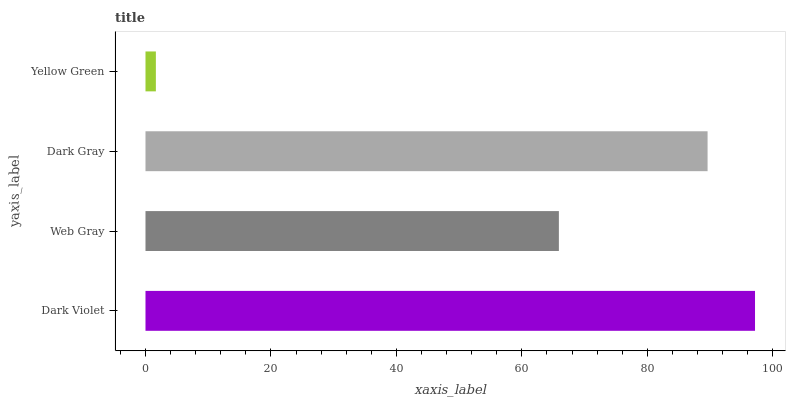Is Yellow Green the minimum?
Answer yes or no. Yes. Is Dark Violet the maximum?
Answer yes or no. Yes. Is Web Gray the minimum?
Answer yes or no. No. Is Web Gray the maximum?
Answer yes or no. No. Is Dark Violet greater than Web Gray?
Answer yes or no. Yes. Is Web Gray less than Dark Violet?
Answer yes or no. Yes. Is Web Gray greater than Dark Violet?
Answer yes or no. No. Is Dark Violet less than Web Gray?
Answer yes or no. No. Is Dark Gray the high median?
Answer yes or no. Yes. Is Web Gray the low median?
Answer yes or no. Yes. Is Yellow Green the high median?
Answer yes or no. No. Is Dark Violet the low median?
Answer yes or no. No. 